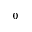<formula> <loc_0><loc_0><loc_500><loc_500>^ { 0 }</formula> 